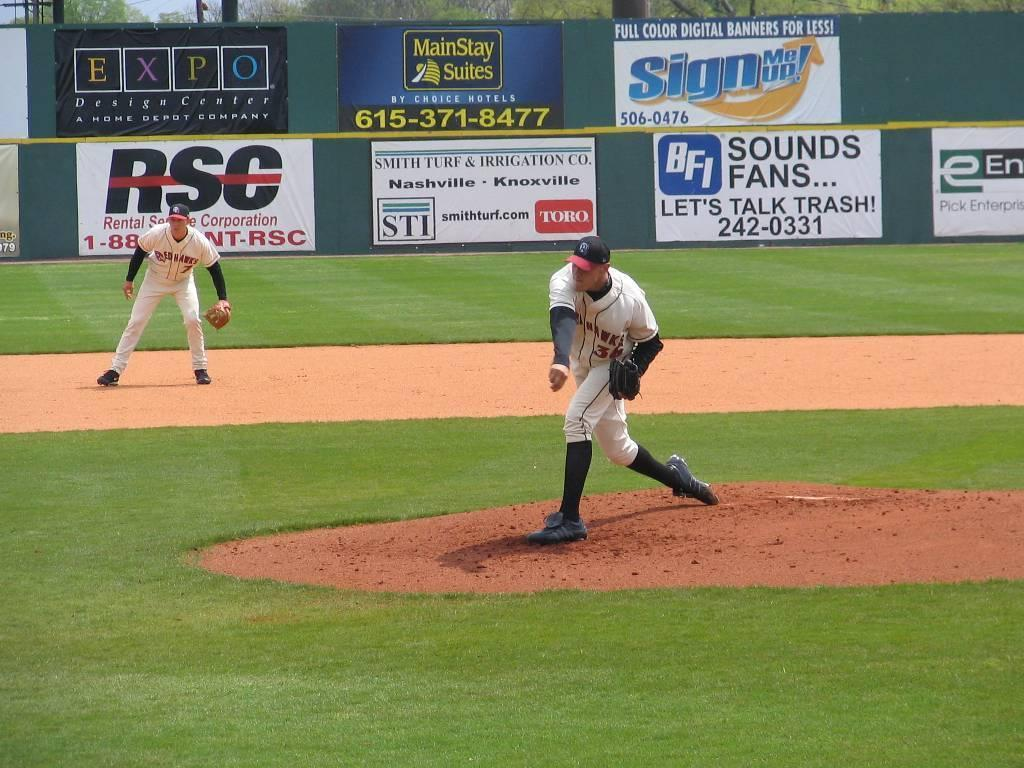<image>
Write a terse but informative summary of the picture. The Redhawks pitcher has just thrown the ball. 